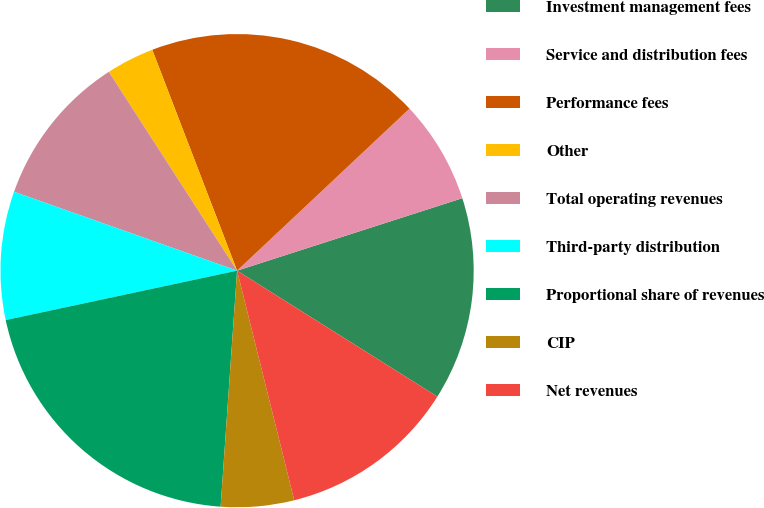Convert chart. <chart><loc_0><loc_0><loc_500><loc_500><pie_chart><fcel>Investment management fees<fcel>Service and distribution fees<fcel>Performance fees<fcel>Other<fcel>Total operating revenues<fcel>Third-party distribution<fcel>Proportional share of revenues<fcel>CIP<fcel>Net revenues<nl><fcel>13.89%<fcel>7.05%<fcel>18.83%<fcel>3.28%<fcel>10.47%<fcel>8.76%<fcel>20.54%<fcel>4.99%<fcel>12.18%<nl></chart> 